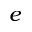<formula> <loc_0><loc_0><loc_500><loc_500>e</formula> 